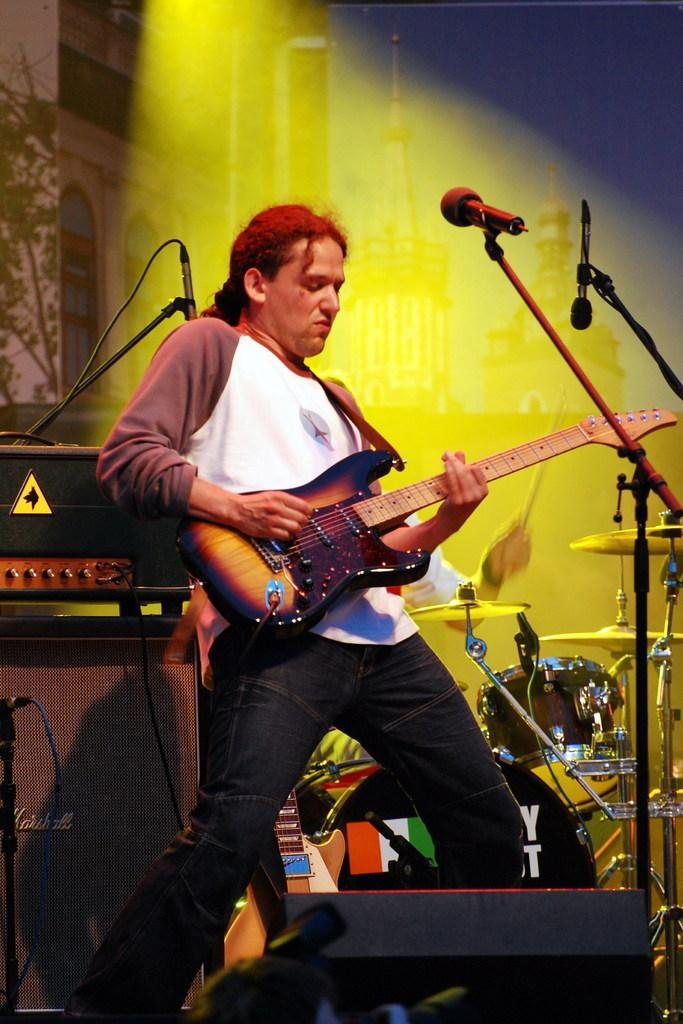What is the man in the image holding? The man is holding a guitar. What object is present in the image that is typically used for amplifying sound? There is a microphone in the image, and it is on a stand. What type of musical instrument can be seen in the image? There is a drum kit in the image. What can be seen in the background of the image that provides illumination? There is lighting in the background of the image. What type of flower is being shaken by the man in the image? There is no flower present in the image, and the man is not shaking anything. 